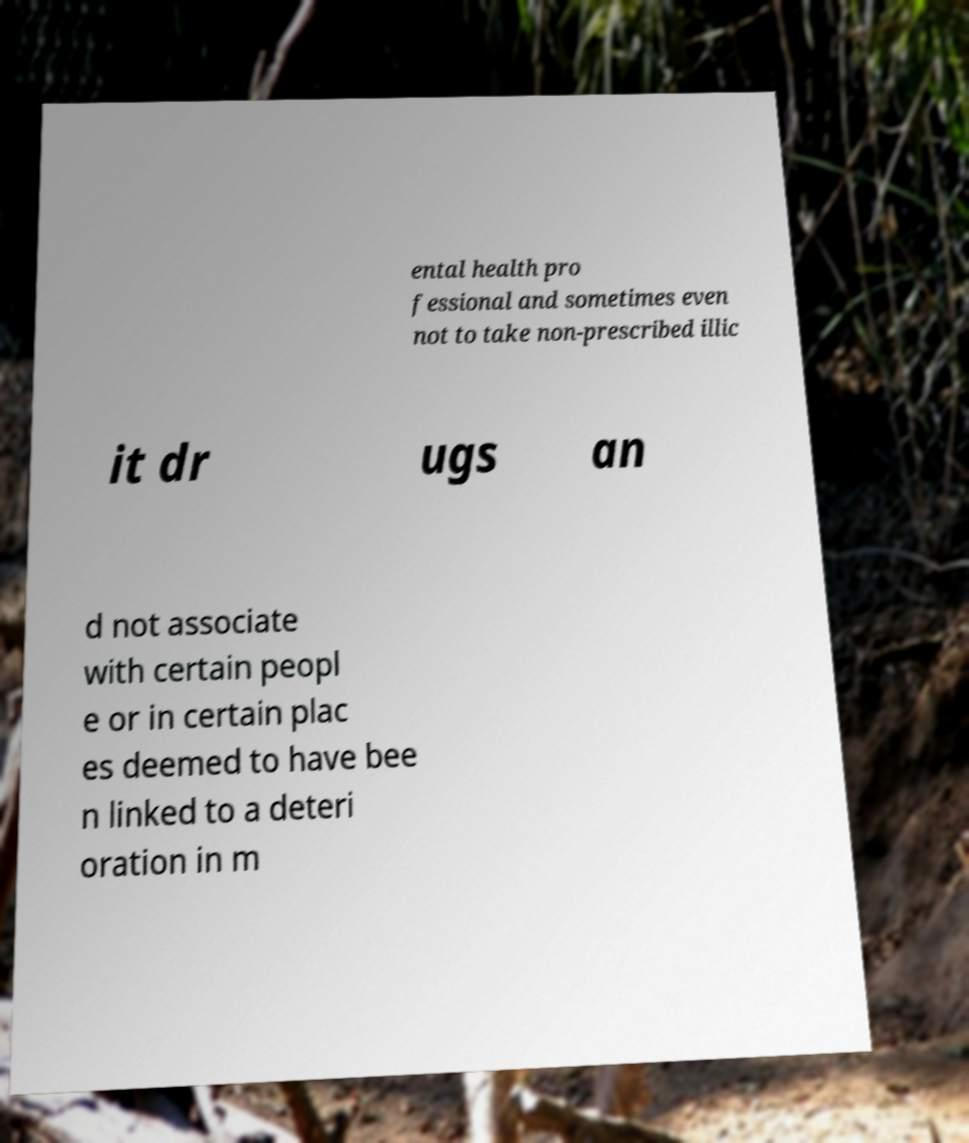Could you extract and type out the text from this image? ental health pro fessional and sometimes even not to take non-prescribed illic it dr ugs an d not associate with certain peopl e or in certain plac es deemed to have bee n linked to a deteri oration in m 